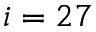<formula> <loc_0><loc_0><loc_500><loc_500>i = 2 7</formula> 